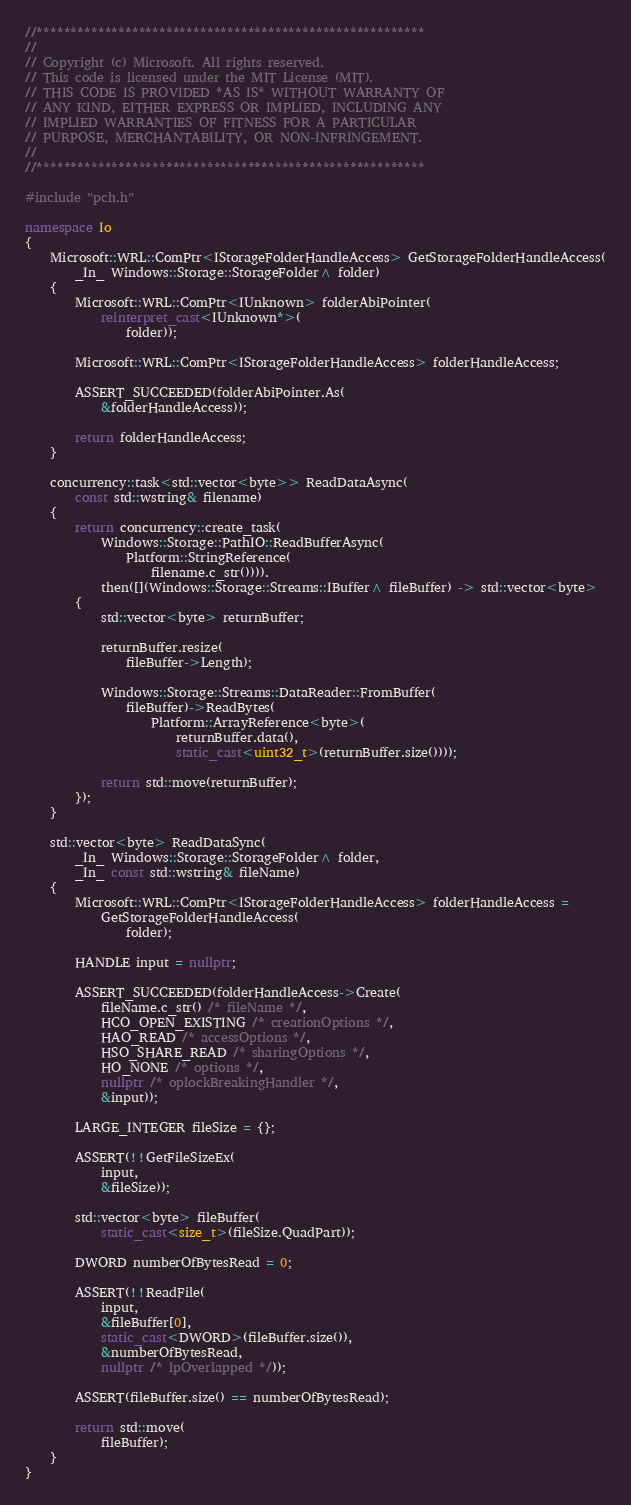Convert code to text. <code><loc_0><loc_0><loc_500><loc_500><_C++_>//*********************************************************
//
// Copyright (c) Microsoft. All rights reserved.
// This code is licensed under the MIT License (MIT).
// THIS CODE IS PROVIDED *AS IS* WITHOUT WARRANTY OF
// ANY KIND, EITHER EXPRESS OR IMPLIED, INCLUDING ANY
// IMPLIED WARRANTIES OF FITNESS FOR A PARTICULAR
// PURPOSE, MERCHANTABILITY, OR NON-INFRINGEMENT.
//
//*********************************************************

#include "pch.h"

namespace Io
{
    Microsoft::WRL::ComPtr<IStorageFolderHandleAccess> GetStorageFolderHandleAccess(
        _In_ Windows::Storage::StorageFolder^ folder)
    {
        Microsoft::WRL::ComPtr<IUnknown> folderAbiPointer(
            reinterpret_cast<IUnknown*>(
                folder));

        Microsoft::WRL::ComPtr<IStorageFolderHandleAccess> folderHandleAccess;

        ASSERT_SUCCEEDED(folderAbiPointer.As(
            &folderHandleAccess));

        return folderHandleAccess;
    }

    concurrency::task<std::vector<byte>> ReadDataAsync(
        const std::wstring& filename)
    {
        return concurrency::create_task(
            Windows::Storage::PathIO::ReadBufferAsync(
                Platform::StringReference(
                    filename.c_str()))).
            then([](Windows::Storage::Streams::IBuffer^ fileBuffer) -> std::vector<byte>
        {
            std::vector<byte> returnBuffer;

            returnBuffer.resize(
                fileBuffer->Length);

            Windows::Storage::Streams::DataReader::FromBuffer(
                fileBuffer)->ReadBytes(
                    Platform::ArrayReference<byte>(
                        returnBuffer.data(),
                        static_cast<uint32_t>(returnBuffer.size())));

            return std::move(returnBuffer);
        });
    }

    std::vector<byte> ReadDataSync(
        _In_ Windows::Storage::StorageFolder^ folder,
        _In_ const std::wstring& fileName)
    {
        Microsoft::WRL::ComPtr<IStorageFolderHandleAccess> folderHandleAccess =
            GetStorageFolderHandleAccess(
                folder);

        HANDLE input = nullptr;

        ASSERT_SUCCEEDED(folderHandleAccess->Create(
            fileName.c_str() /* fileName */,
            HCO_OPEN_EXISTING /* creationOptions */,
            HAO_READ /* accessOptions */,
            HSO_SHARE_READ /* sharingOptions */,
            HO_NONE /* options */,
            nullptr /* oplockBreakingHandler */,
            &input));

        LARGE_INTEGER fileSize = {};

        ASSERT(!!GetFileSizeEx(
            input,
            &fileSize));

        std::vector<byte> fileBuffer(
            static_cast<size_t>(fileSize.QuadPart));

        DWORD numberOfBytesRead = 0;

        ASSERT(!!ReadFile(
            input,
            &fileBuffer[0],
            static_cast<DWORD>(fileBuffer.size()),
            &numberOfBytesRead,
            nullptr /* lpOverlapped */));

        ASSERT(fileBuffer.size() == numberOfBytesRead);

        return std::move(
            fileBuffer);
    }
}
</code> 